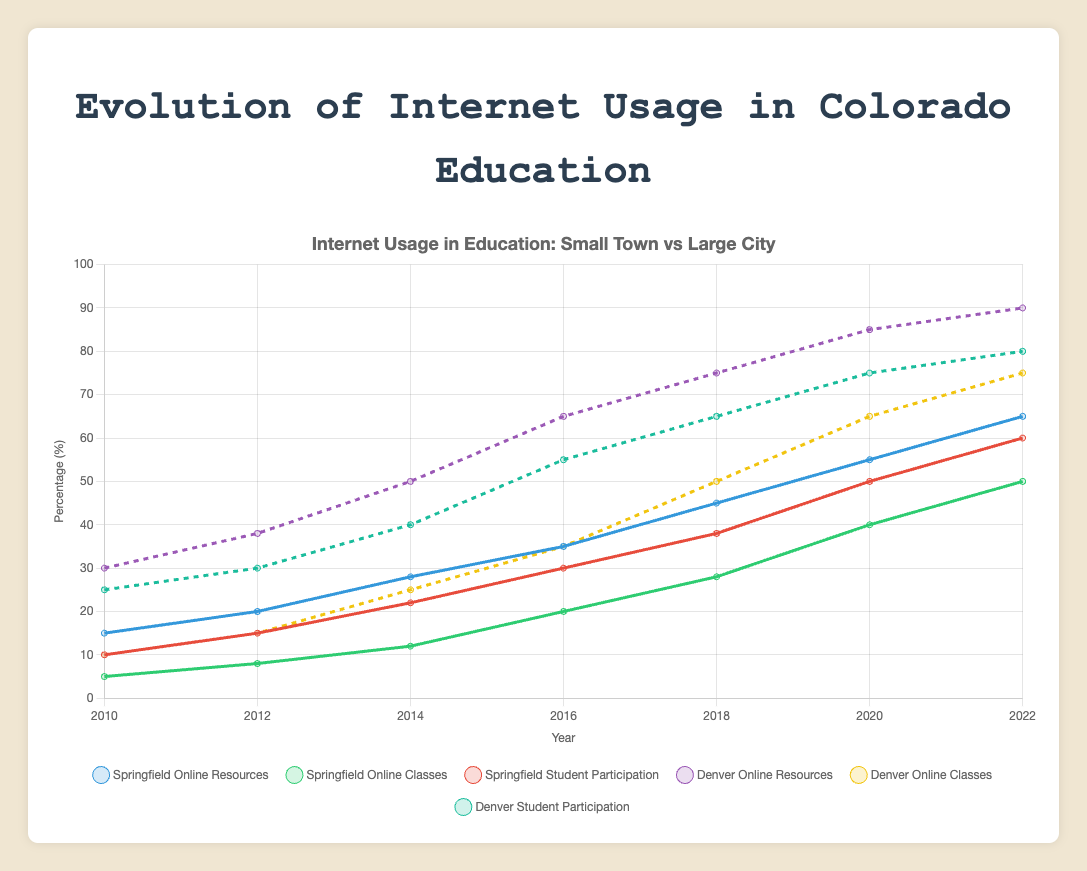Which city has the highest percentage of student participation in 2022? To find the highest percentage, look at the end of the 'Student Participation' lines. Compare the final percentages for Denver and Colorado Springs in the large city category. Denver has 80% and Colorado Springs has 78%. Denver has the highest percentage.
Answer: Denver What is the difference in online resources usage between Springfield and Denver in 2016? Check the 'Online Resources' lines for Springfield and Denver in 2016. Springfield has 35%, and Denver has 65%. Subtract Springfield's percentage from Denver's. 65% - 35% = 30%. The difference is 30%.
Answer: 30% By how many percentage points did Delta's online classes usage increase from 2016 to 2020? Look at Delta’s 'Online Classes' line in 2016 and 2020. It went from 18% in 2016 to 38% in 2020. Subtract 18% from 38%. 38% - 18% = 20%. The increase is 20 percentage points.
Answer: 20 Between 2010 and 2022, which city had the highest overall increase in the usage of online resources? Calculate the increase for each city from 2010 to 2022 by subtracting the 2010 percentage from the 2022 percentage. Springfield's increase: 65% - 15% = 50%, Delta's increase: 62% - 12% = 50%, Denver's increase: 90% - 30% = 60%, Colorado Springs' increase: 88% - 28% = 60%. Denver and Colorado Springs both had the highest increase of 60 percentage points.
Answer: Denver and Colorado Springs Which has grown more rapidly in Springfield: online classes or student participation from 2010 to 2022? For Springfield, calculate the percentage increase for both metrics from 2010 to 2022. Online Classes: (50% - 5%) = 45%, Student Participation: (60% - 10%) = 50%. Compare the increases, 50% > 45%, so student participation has grown more rapidly.
Answer: Student participation In 2018, what is the average percentage of online classes usage in small towns (Springfield and Delta)? Add the percentages of online classes usage in Springfield and Delta for 2018, then divide by 2. Springfield: 28%, Delta: 25%. (28% + 25%) / 2 = 26.5%. The average is 26.5%.
Answer: 26.5% Which town or city showed the steadiest growth in online resources usage from 2010 to 2022? Examine the 'Online Resources' lines for a consistent upward trend with no large fluctuations. Springfield: 15, 20, 28, 35, 45, 55, 65. Delta: 12, 18, 25, 33, 42, 52, 62. Denver: 30, 38, 50, 65, 75, 85, 90. Colorado Springs: 28, 35, 48, 60, 70, 80, 88. Denver had steady increments without large fluctuations.
Answer: Denver How many more percentage points did Denver students participate in online activities compared to Delta students in 2022? Check the 'Student Participation' percentages for Denver and Delta in 2022. Denver has 80%, and Delta has 58%. Subtract Delta's percentage from Denver's. 80% - 58% = 22%. The difference is 22 percentage points.
Answer: 22 